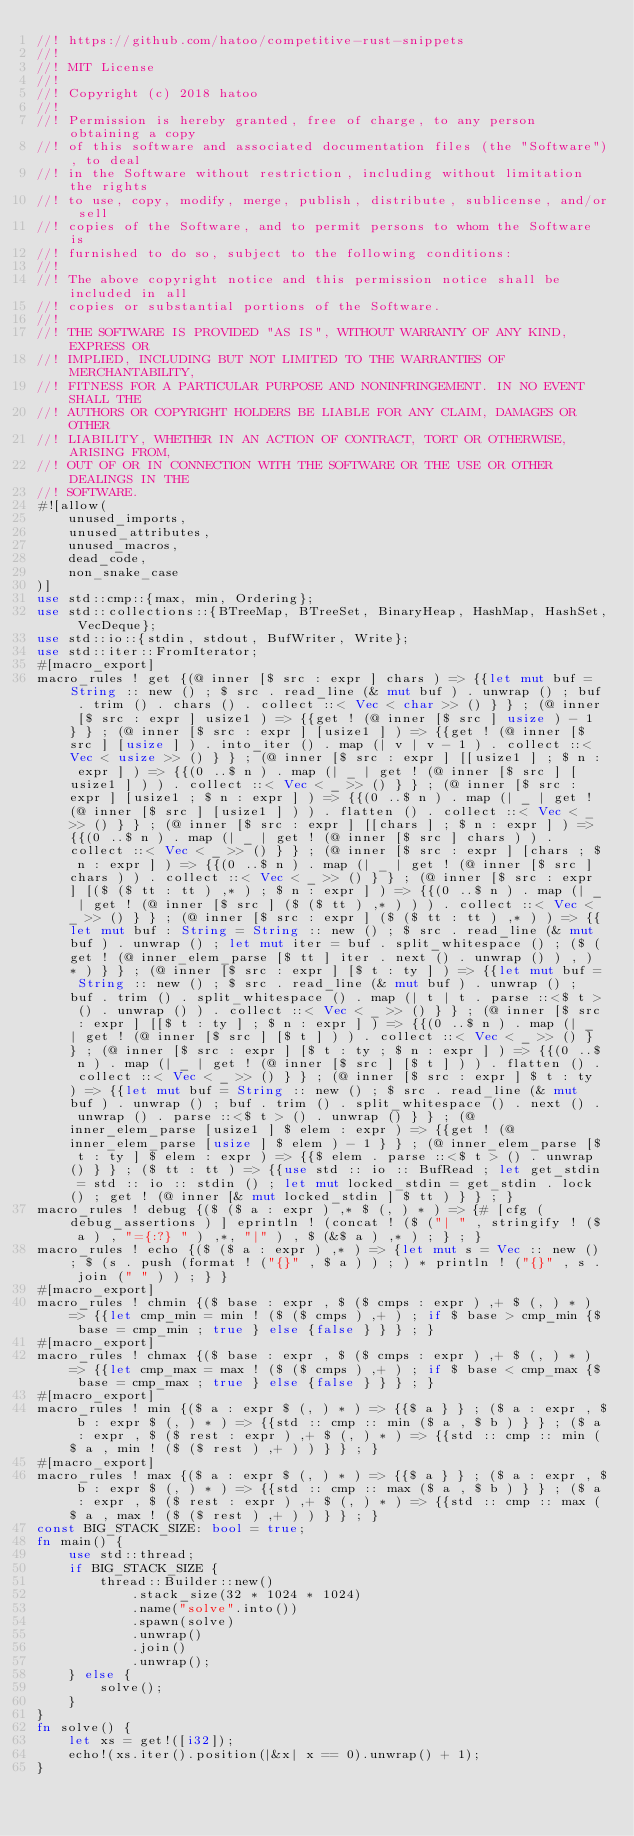Convert code to text. <code><loc_0><loc_0><loc_500><loc_500><_Rust_>//! https://github.com/hatoo/competitive-rust-snippets
//!
//! MIT License
//!
//! Copyright (c) 2018 hatoo
//!
//! Permission is hereby granted, free of charge, to any person obtaining a copy
//! of this software and associated documentation files (the "Software"), to deal
//! in the Software without restriction, including without limitation the rights
//! to use, copy, modify, merge, publish, distribute, sublicense, and/or sell
//! copies of the Software, and to permit persons to whom the Software is
//! furnished to do so, subject to the following conditions:
//!
//! The above copyright notice and this permission notice shall be included in all
//! copies or substantial portions of the Software.
//!
//! THE SOFTWARE IS PROVIDED "AS IS", WITHOUT WARRANTY OF ANY KIND, EXPRESS OR
//! IMPLIED, INCLUDING BUT NOT LIMITED TO THE WARRANTIES OF MERCHANTABILITY,
//! FITNESS FOR A PARTICULAR PURPOSE AND NONINFRINGEMENT. IN NO EVENT SHALL THE
//! AUTHORS OR COPYRIGHT HOLDERS BE LIABLE FOR ANY CLAIM, DAMAGES OR OTHER
//! LIABILITY, WHETHER IN AN ACTION OF CONTRACT, TORT OR OTHERWISE, ARISING FROM,
//! OUT OF OR IN CONNECTION WITH THE SOFTWARE OR THE USE OR OTHER DEALINGS IN THE
//! SOFTWARE.
#![allow(
    unused_imports,
    unused_attributes,
    unused_macros,
    dead_code,
    non_snake_case
)]
use std::cmp::{max, min, Ordering};
use std::collections::{BTreeMap, BTreeSet, BinaryHeap, HashMap, HashSet, VecDeque};
use std::io::{stdin, stdout, BufWriter, Write};
use std::iter::FromIterator;
#[macro_export]
macro_rules ! get {(@ inner [$ src : expr ] chars ) => {{let mut buf = String :: new () ; $ src . read_line (& mut buf ) . unwrap () ; buf . trim () . chars () . collect ::< Vec < char >> () } } ; (@ inner [$ src : expr ] usize1 ) => {{get ! (@ inner [$ src ] usize ) - 1 } } ; (@ inner [$ src : expr ] [usize1 ] ) => {{get ! (@ inner [$ src ] [usize ] ) . into_iter () . map (| v | v - 1 ) . collect ::< Vec < usize >> () } } ; (@ inner [$ src : expr ] [[usize1 ] ; $ n : expr ] ) => {{(0 ..$ n ) . map (| _ | get ! (@ inner [$ src ] [usize1 ] ) ) . collect ::< Vec < _ >> () } } ; (@ inner [$ src : expr ] [usize1 ; $ n : expr ] ) => {{(0 ..$ n ) . map (| _ | get ! (@ inner [$ src ] [usize1 ] ) ) . flatten () . collect ::< Vec < _ >> () } } ; (@ inner [$ src : expr ] [[chars ] ; $ n : expr ] ) => {{(0 ..$ n ) . map (| _ | get ! (@ inner [$ src ] chars ) ) . collect ::< Vec < _ >> () } } ; (@ inner [$ src : expr ] [chars ; $ n : expr ] ) => {{(0 ..$ n ) . map (| _ | get ! (@ inner [$ src ] chars ) ) . collect ::< Vec < _ >> () } } ; (@ inner [$ src : expr ] [($ ($ tt : tt ) ,* ) ; $ n : expr ] ) => {{(0 ..$ n ) . map (| _ | get ! (@ inner [$ src ] ($ ($ tt ) ,* ) ) ) . collect ::< Vec < _ >> () } } ; (@ inner [$ src : expr ] ($ ($ tt : tt ) ,* ) ) => {{let mut buf : String = String :: new () ; $ src . read_line (& mut buf ) . unwrap () ; let mut iter = buf . split_whitespace () ; ($ (get ! (@ inner_elem_parse [$ tt ] iter . next () . unwrap () ) , ) * ) } } ; (@ inner [$ src : expr ] [$ t : ty ] ) => {{let mut buf = String :: new () ; $ src . read_line (& mut buf ) . unwrap () ; buf . trim () . split_whitespace () . map (| t | t . parse ::<$ t > () . unwrap () ) . collect ::< Vec < _ >> () } } ; (@ inner [$ src : expr ] [[$ t : ty ] ; $ n : expr ] ) => {{(0 ..$ n ) . map (| _ | get ! (@ inner [$ src ] [$ t ] ) ) . collect ::< Vec < _ >> () } } ; (@ inner [$ src : expr ] [$ t : ty ; $ n : expr ] ) => {{(0 ..$ n ) . map (| _ | get ! (@ inner [$ src ] [$ t ] ) ) . flatten () . collect ::< Vec < _ >> () } } ; (@ inner [$ src : expr ] $ t : ty ) => {{let mut buf = String :: new () ; $ src . read_line (& mut buf ) . unwrap () ; buf . trim () . split_whitespace () . next () . unwrap () . parse ::<$ t > () . unwrap () } } ; (@ inner_elem_parse [usize1 ] $ elem : expr ) => {{get ! (@ inner_elem_parse [usize ] $ elem ) - 1 } } ; (@ inner_elem_parse [$ t : ty ] $ elem : expr ) => {{$ elem . parse ::<$ t > () . unwrap () } } ; ($ tt : tt ) => {{use std :: io :: BufRead ; let get_stdin = std :: io :: stdin () ; let mut locked_stdin = get_stdin . lock () ; get ! (@ inner [& mut locked_stdin ] $ tt ) } } ; }
macro_rules ! debug {($ ($ a : expr ) ,* $ (, ) * ) => {# [cfg (debug_assertions ) ] eprintln ! (concat ! ($ ("| " , stringify ! ($ a ) , "={:?} " ) ,*, "|" ) , $ (&$ a ) ,* ) ; } ; }
macro_rules ! echo {($ ($ a : expr ) ,* ) => {let mut s = Vec :: new () ; $ (s . push (format ! ("{}" , $ a ) ) ; ) * println ! ("{}" , s . join (" " ) ) ; } }
#[macro_export]
macro_rules ! chmin {($ base : expr , $ ($ cmps : expr ) ,+ $ (, ) * ) => {{let cmp_min = min ! ($ ($ cmps ) ,+ ) ; if $ base > cmp_min {$ base = cmp_min ; true } else {false } } } ; }
#[macro_export]
macro_rules ! chmax {($ base : expr , $ ($ cmps : expr ) ,+ $ (, ) * ) => {{let cmp_max = max ! ($ ($ cmps ) ,+ ) ; if $ base < cmp_max {$ base = cmp_max ; true } else {false } } } ; }
#[macro_export]
macro_rules ! min {($ a : expr $ (, ) * ) => {{$ a } } ; ($ a : expr , $ b : expr $ (, ) * ) => {{std :: cmp :: min ($ a , $ b ) } } ; ($ a : expr , $ ($ rest : expr ) ,+ $ (, ) * ) => {{std :: cmp :: min ($ a , min ! ($ ($ rest ) ,+ ) ) } } ; }
#[macro_export]
macro_rules ! max {($ a : expr $ (, ) * ) => {{$ a } } ; ($ a : expr , $ b : expr $ (, ) * ) => {{std :: cmp :: max ($ a , $ b ) } } ; ($ a : expr , $ ($ rest : expr ) ,+ $ (, ) * ) => {{std :: cmp :: max ($ a , max ! ($ ($ rest ) ,+ ) ) } } ; }
const BIG_STACK_SIZE: bool = true;
fn main() {
    use std::thread;
    if BIG_STACK_SIZE {
        thread::Builder::new()
            .stack_size(32 * 1024 * 1024)
            .name("solve".into())
            .spawn(solve)
            .unwrap()
            .join()
            .unwrap();
    } else {
        solve();
    }
}
fn solve() {
    let xs = get!([i32]);
    echo!(xs.iter().position(|&x| x == 0).unwrap() + 1);
}
</code> 